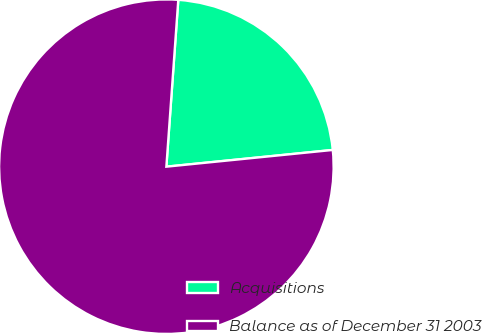Convert chart to OTSL. <chart><loc_0><loc_0><loc_500><loc_500><pie_chart><fcel>Acquisitions<fcel>Balance as of December 31 2003<nl><fcel>22.27%<fcel>77.73%<nl></chart> 